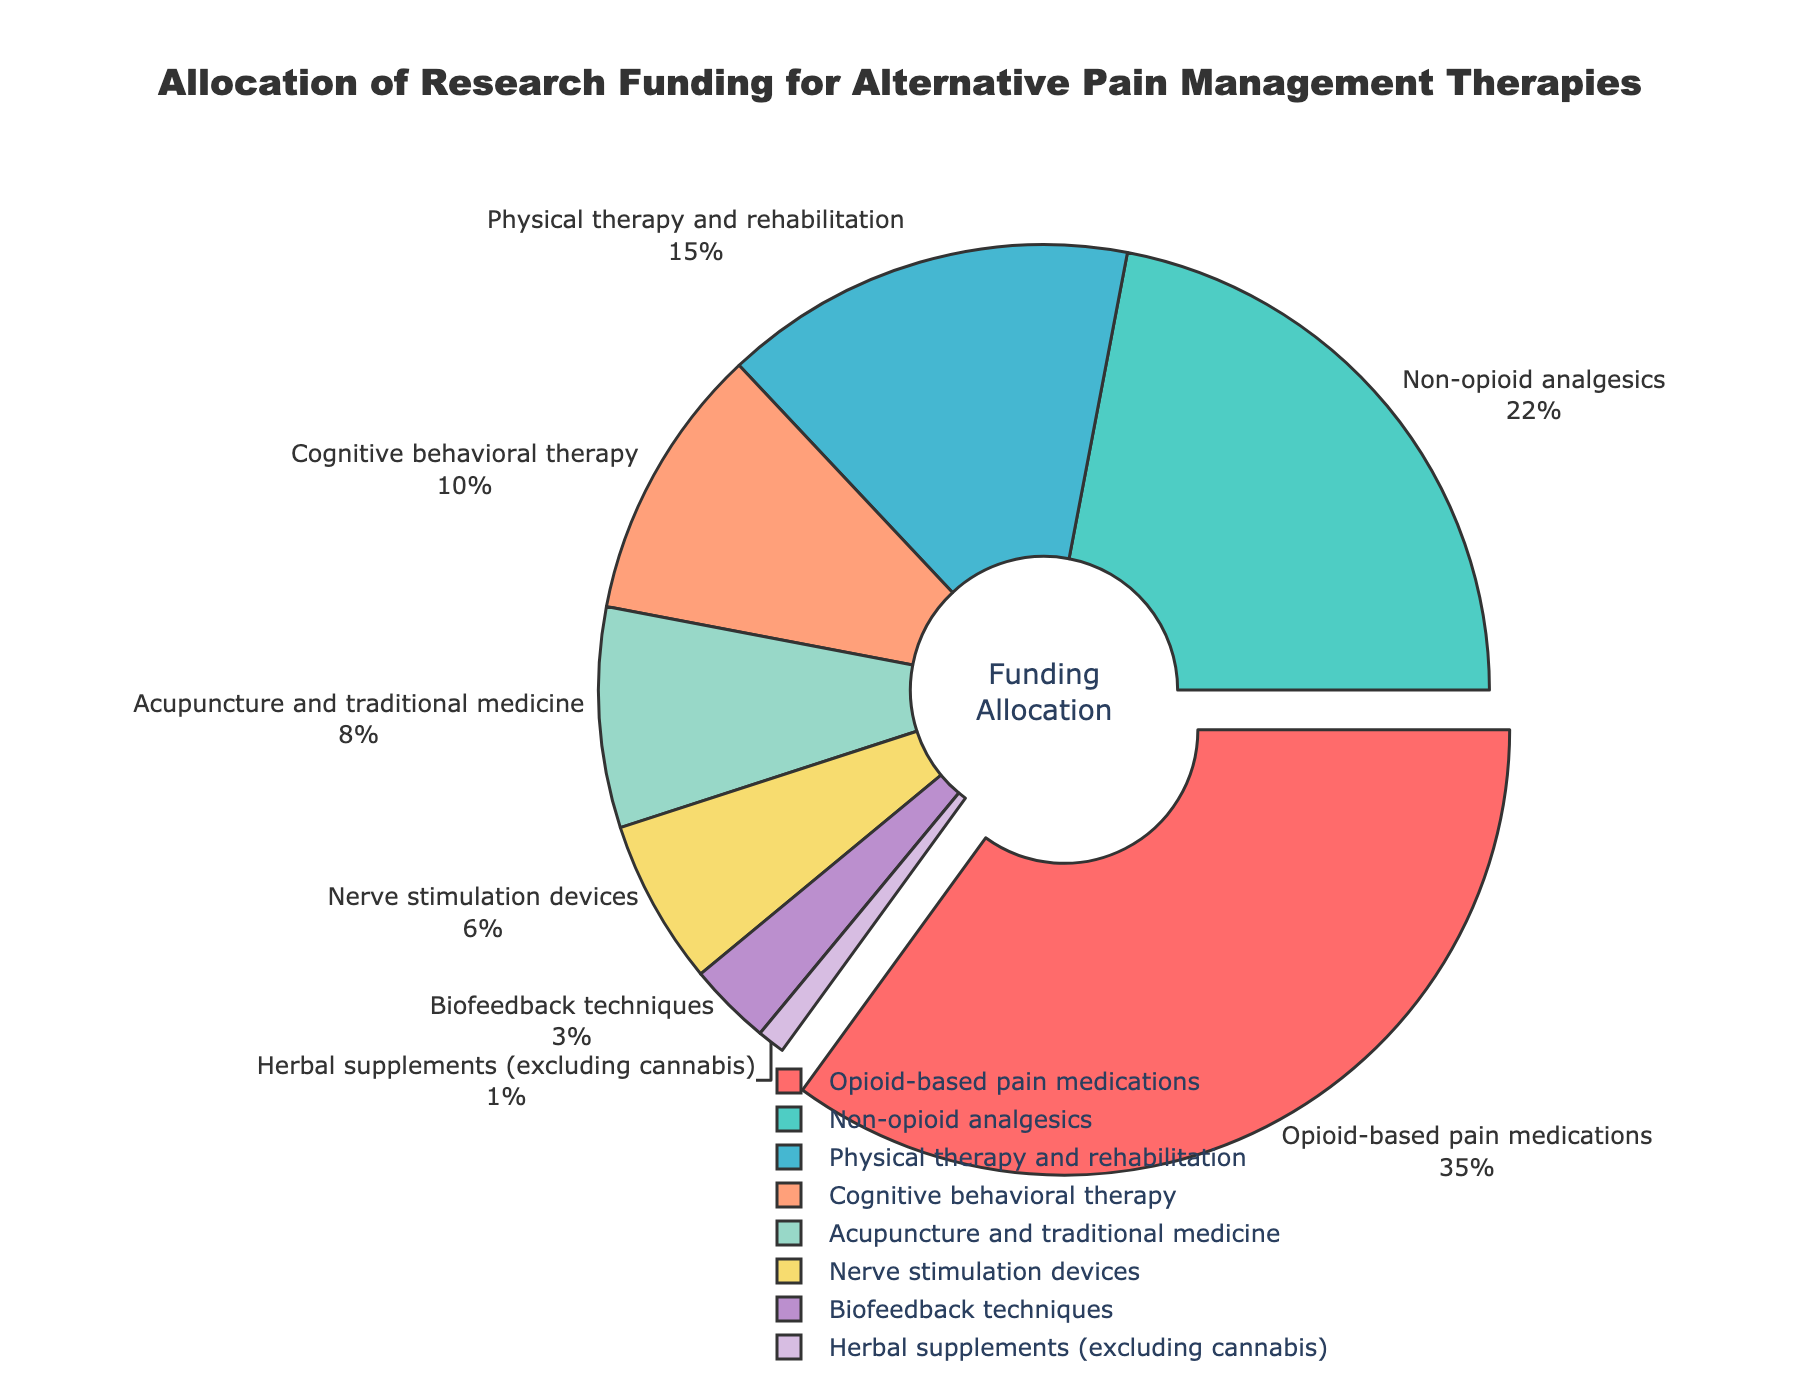What is the largest allocation of research funding for a single therapy? By observing the pie chart, we can identify which segment has the largest percentage associated with it. According to the chart, the largest funding allocation is for opioid-based pain medications.
Answer: 35% How does the funding for non-opioid analgesics compare to that for physical therapy and rehabilitation? We need to find and compare the percentages of funding allocated to non-opioid analgesics and physical therapy and rehabilitation. The former has 22% while the latter has 15%. By comparing them, we see that non-opioid analgesics receive more funding.
Answer: Non-opioid analgesics have 7% more funding than physical therapy and rehabilitation Which alternative therapy receives the least research funding? The smallest segment of the pie chart represents the therapy with the least funding. From the data, herbal supplements (excluding cannabis) have the least funding at 1%.
Answer: Herbal supplements (excluding cannabis) What is the total percentage of funding allocated to cognitive behavioral therapy and acupuncture/traditional medicine combined? We need to sum the funding percentages of cognitive behavioral therapy and acupuncture/traditional medicine. These are 10% and 8% respectively. Adding them gives 10% + 8% = 18%.
Answer: 18% How does the allocation for nerve stimulation devices compare to biofeedback techniques? Identify the percentages allocated to nerve stimulation devices and biofeedback techniques, which are 6% and 3% respectively. Comparing them shows that nerve stimulation devices receive double the funding of biofeedback techniques.
Answer: Nerve stimulation devices receive twice the funding of biofeedback techniques What percentage of research funding is allocated to therapies other than opioid-based pain medications? To find this, we subtract the funding for opioid-based pain medications (35%) from the total funding (100%). So, 100% - 35% = 65%.
Answer: 65% If you combine the funding for acupuncture/traditional medicine and nerve stimulation devices, is it more than the funding for non-opioid analgesics? First, add the percentages for acupuncture/traditional medicine (8%) and nerve stimulation devices (6%). This equals 14%. Since non-opioid analgesics have 22%, 14% is less than 22%.
Answer: No What is the difference between the largest and smallest funding allocations? Identify the largest (opioid-based pain medications at 35%) and the smallest (herbal supplements at 1%) allocations. Subtract the smallest from the largest to determine the difference: 35% - 1% = 34%.
Answer: 34% Which therapy's funding is closest to 10%? We need to find the segment whose percentage is closest to 10%. Cognitive behavioral therapy is allocated exactly 10%.
Answer: Cognitive behavioral therapy What therapies have a lower funding allocation than cognitive behavioral therapy? Cognitive behavioral therapy has 10% funding. Therapies with less than 10% are acupuncture and traditional medicine (8%), nerve stimulation devices (6%), biofeedback techniques (3%), and herbal supplements (excluding cannabis) (1%).
Answer: Acupuncture and traditional medicine, nerve stimulation devices, biofeedback techniques, and herbal supplements (excluding cannabis) 